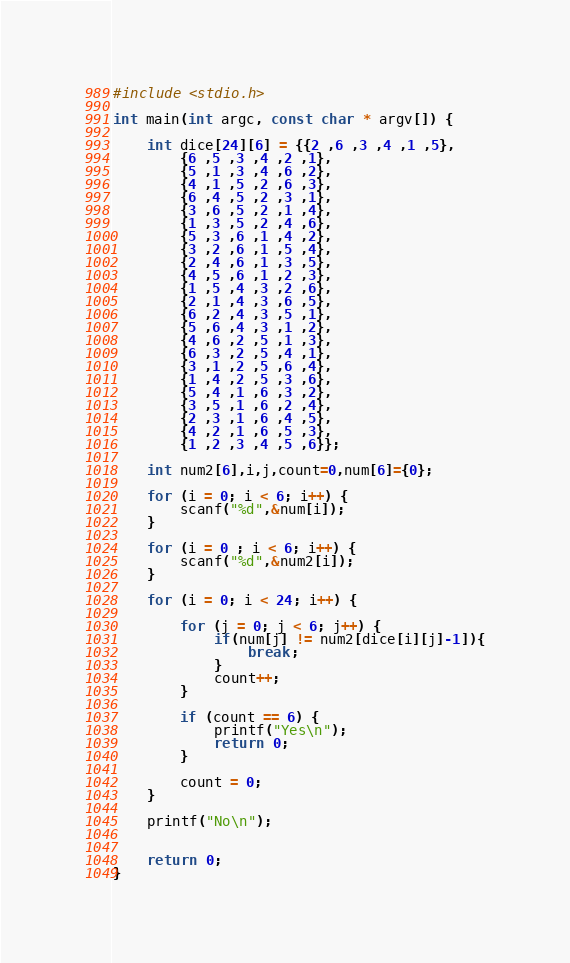<code> <loc_0><loc_0><loc_500><loc_500><_C_>#include <stdio.h>

int main(int argc, const char * argv[]) {
    
    int dice[24][6] = {{2 ,6 ,3 ,4 ,1 ,5},
        {6 ,5 ,3 ,4 ,2 ,1},
        {5 ,1 ,3 ,4 ,6 ,2},
        {4 ,1 ,5 ,2 ,6 ,3},
        {6 ,4 ,5 ,2 ,3 ,1},
        {3 ,6 ,5 ,2 ,1 ,4},
        {1 ,3 ,5 ,2 ,4 ,6},
        {5 ,3 ,6 ,1 ,4 ,2},
        {3 ,2 ,6 ,1 ,5 ,4},
        {2 ,4 ,6 ,1 ,3 ,5},
        {4 ,5 ,6 ,1 ,2 ,3},
        {1 ,5 ,4 ,3 ,2 ,6},
        {2 ,1 ,4 ,3 ,6 ,5},
        {6 ,2 ,4 ,3 ,5 ,1},
        {5 ,6 ,4 ,3 ,1 ,2},
        {4 ,6 ,2 ,5 ,1 ,3},
        {6 ,3 ,2 ,5 ,4 ,1},
        {3 ,1 ,2 ,5 ,6 ,4},
        {1 ,4 ,2 ,5 ,3 ,6},
        {5 ,4 ,1 ,6 ,3 ,2},
        {3 ,5 ,1 ,6 ,2 ,4},
        {2 ,3 ,1 ,6 ,4 ,5},
        {4 ,2 ,1 ,6 ,5 ,3},
        {1 ,2 ,3 ,4 ,5 ,6}};
    
    int num2[6],i,j,count=0,num[6]={0};
    
    for (i = 0; i < 6; i++) {
        scanf("%d",&num[i]);
    }
    
    for (i = 0 ; i < 6; i++) {
        scanf("%d",&num2[i]);
    }
    
    for (i = 0; i < 24; i++) {
        
        for (j = 0; j < 6; j++) {
            if(num[j] != num2[dice[i][j]-1]){
                break;
            }
            count++;
        }
        
        if (count == 6) {
            printf("Yes\n");
            return 0;
        }
        
        count = 0;
    }
    
    printf("No\n");
    
    
    return 0;
}
</code> 